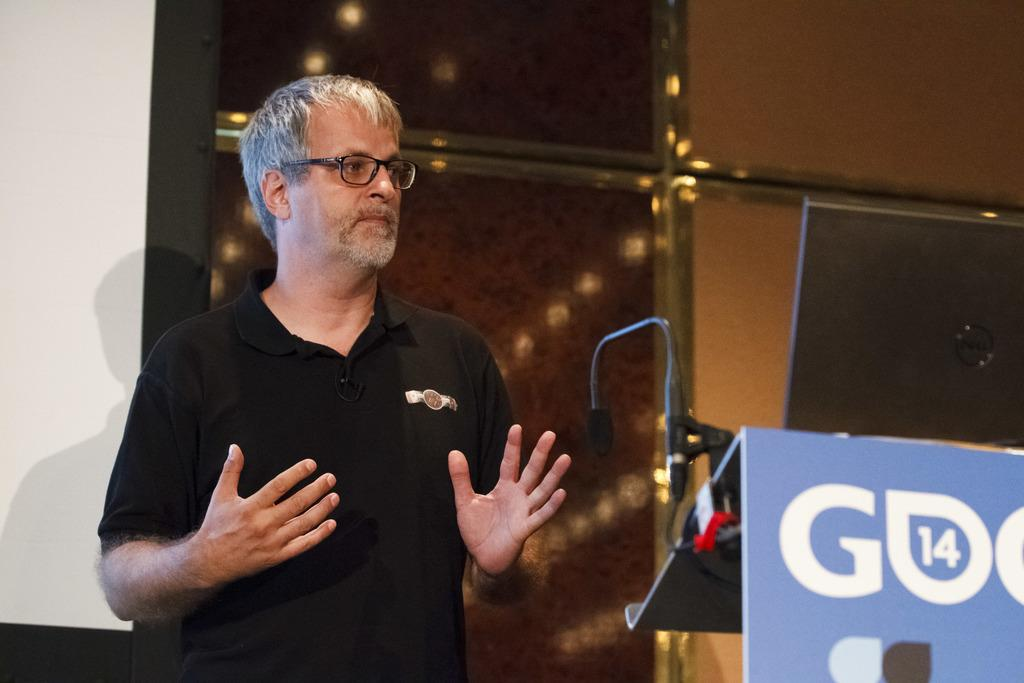Who is present in the image? There is a man in the image. What is the man wearing? The man is wearing spectacles. What is the man doing in the image? The man is standing at a podium. What device is visible in the image? There is a laptop in the image. What can be seen in the background of the image? There is a wall in the background of the image. What type of pipe is the man smoking in the image? There is no pipe present in the image; the man is wearing spectacles and standing at a podium. 